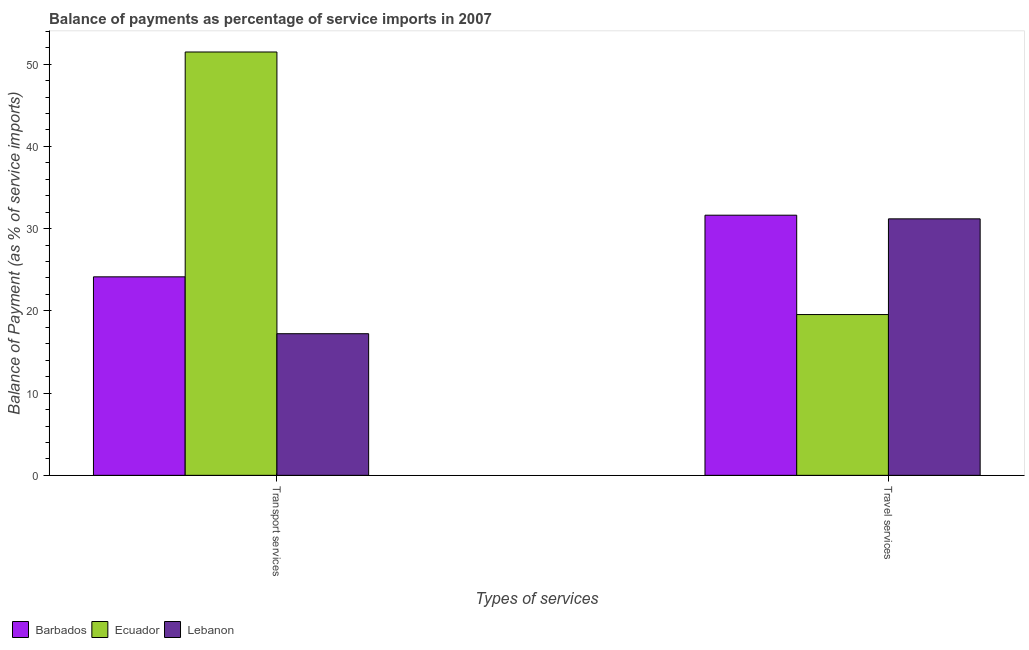How many groups of bars are there?
Your response must be concise. 2. Are the number of bars per tick equal to the number of legend labels?
Provide a succinct answer. Yes. Are the number of bars on each tick of the X-axis equal?
Give a very brief answer. Yes. How many bars are there on the 1st tick from the right?
Your answer should be very brief. 3. What is the label of the 2nd group of bars from the left?
Offer a very short reply. Travel services. What is the balance of payments of travel services in Ecuador?
Offer a very short reply. 19.55. Across all countries, what is the maximum balance of payments of travel services?
Ensure brevity in your answer.  31.64. Across all countries, what is the minimum balance of payments of transport services?
Provide a short and direct response. 17.22. In which country was the balance of payments of travel services maximum?
Provide a succinct answer. Barbados. In which country was the balance of payments of travel services minimum?
Offer a terse response. Ecuador. What is the total balance of payments of transport services in the graph?
Offer a very short reply. 92.85. What is the difference between the balance of payments of travel services in Lebanon and that in Ecuador?
Make the answer very short. 11.64. What is the difference between the balance of payments of travel services in Barbados and the balance of payments of transport services in Lebanon?
Your answer should be very brief. 14.41. What is the average balance of payments of transport services per country?
Offer a very short reply. 30.95. What is the difference between the balance of payments of travel services and balance of payments of transport services in Barbados?
Offer a terse response. 7.49. What is the ratio of the balance of payments of travel services in Ecuador to that in Lebanon?
Make the answer very short. 0.63. What does the 3rd bar from the left in Transport services represents?
Provide a short and direct response. Lebanon. What does the 1st bar from the right in Travel services represents?
Provide a short and direct response. Lebanon. How many countries are there in the graph?
Make the answer very short. 3. What is the difference between two consecutive major ticks on the Y-axis?
Make the answer very short. 10. Are the values on the major ticks of Y-axis written in scientific E-notation?
Offer a terse response. No. Does the graph contain any zero values?
Your answer should be compact. No. Does the graph contain grids?
Give a very brief answer. No. What is the title of the graph?
Offer a terse response. Balance of payments as percentage of service imports in 2007. Does "Low income" appear as one of the legend labels in the graph?
Your answer should be very brief. No. What is the label or title of the X-axis?
Provide a succinct answer. Types of services. What is the label or title of the Y-axis?
Make the answer very short. Balance of Payment (as % of service imports). What is the Balance of Payment (as % of service imports) of Barbados in Transport services?
Make the answer very short. 24.14. What is the Balance of Payment (as % of service imports) of Ecuador in Transport services?
Keep it short and to the point. 51.48. What is the Balance of Payment (as % of service imports) of Lebanon in Transport services?
Your response must be concise. 17.22. What is the Balance of Payment (as % of service imports) of Barbados in Travel services?
Provide a succinct answer. 31.64. What is the Balance of Payment (as % of service imports) in Ecuador in Travel services?
Give a very brief answer. 19.55. What is the Balance of Payment (as % of service imports) in Lebanon in Travel services?
Keep it short and to the point. 31.19. Across all Types of services, what is the maximum Balance of Payment (as % of service imports) in Barbados?
Your response must be concise. 31.64. Across all Types of services, what is the maximum Balance of Payment (as % of service imports) of Ecuador?
Provide a short and direct response. 51.48. Across all Types of services, what is the maximum Balance of Payment (as % of service imports) of Lebanon?
Your answer should be very brief. 31.19. Across all Types of services, what is the minimum Balance of Payment (as % of service imports) in Barbados?
Provide a succinct answer. 24.14. Across all Types of services, what is the minimum Balance of Payment (as % of service imports) in Ecuador?
Keep it short and to the point. 19.55. Across all Types of services, what is the minimum Balance of Payment (as % of service imports) of Lebanon?
Provide a succinct answer. 17.22. What is the total Balance of Payment (as % of service imports) of Barbados in the graph?
Offer a terse response. 55.78. What is the total Balance of Payment (as % of service imports) in Ecuador in the graph?
Offer a very short reply. 71.03. What is the total Balance of Payment (as % of service imports) of Lebanon in the graph?
Offer a terse response. 48.41. What is the difference between the Balance of Payment (as % of service imports) in Barbados in Transport services and that in Travel services?
Make the answer very short. -7.49. What is the difference between the Balance of Payment (as % of service imports) of Ecuador in Transport services and that in Travel services?
Offer a terse response. 31.93. What is the difference between the Balance of Payment (as % of service imports) of Lebanon in Transport services and that in Travel services?
Keep it short and to the point. -13.97. What is the difference between the Balance of Payment (as % of service imports) of Barbados in Transport services and the Balance of Payment (as % of service imports) of Ecuador in Travel services?
Give a very brief answer. 4.59. What is the difference between the Balance of Payment (as % of service imports) in Barbados in Transport services and the Balance of Payment (as % of service imports) in Lebanon in Travel services?
Give a very brief answer. -7.05. What is the difference between the Balance of Payment (as % of service imports) in Ecuador in Transport services and the Balance of Payment (as % of service imports) in Lebanon in Travel services?
Offer a very short reply. 20.29. What is the average Balance of Payment (as % of service imports) in Barbados per Types of services?
Give a very brief answer. 27.89. What is the average Balance of Payment (as % of service imports) in Ecuador per Types of services?
Offer a terse response. 35.52. What is the average Balance of Payment (as % of service imports) in Lebanon per Types of services?
Provide a succinct answer. 24.21. What is the difference between the Balance of Payment (as % of service imports) in Barbados and Balance of Payment (as % of service imports) in Ecuador in Transport services?
Provide a short and direct response. -27.34. What is the difference between the Balance of Payment (as % of service imports) of Barbados and Balance of Payment (as % of service imports) of Lebanon in Transport services?
Keep it short and to the point. 6.92. What is the difference between the Balance of Payment (as % of service imports) of Ecuador and Balance of Payment (as % of service imports) of Lebanon in Transport services?
Provide a short and direct response. 34.26. What is the difference between the Balance of Payment (as % of service imports) of Barbados and Balance of Payment (as % of service imports) of Ecuador in Travel services?
Provide a short and direct response. 12.08. What is the difference between the Balance of Payment (as % of service imports) in Barbados and Balance of Payment (as % of service imports) in Lebanon in Travel services?
Offer a very short reply. 0.44. What is the difference between the Balance of Payment (as % of service imports) in Ecuador and Balance of Payment (as % of service imports) in Lebanon in Travel services?
Keep it short and to the point. -11.64. What is the ratio of the Balance of Payment (as % of service imports) of Barbados in Transport services to that in Travel services?
Your answer should be compact. 0.76. What is the ratio of the Balance of Payment (as % of service imports) in Ecuador in Transport services to that in Travel services?
Your answer should be compact. 2.63. What is the ratio of the Balance of Payment (as % of service imports) of Lebanon in Transport services to that in Travel services?
Your answer should be compact. 0.55. What is the difference between the highest and the second highest Balance of Payment (as % of service imports) of Barbados?
Make the answer very short. 7.49. What is the difference between the highest and the second highest Balance of Payment (as % of service imports) of Ecuador?
Ensure brevity in your answer.  31.93. What is the difference between the highest and the second highest Balance of Payment (as % of service imports) in Lebanon?
Your answer should be compact. 13.97. What is the difference between the highest and the lowest Balance of Payment (as % of service imports) of Barbados?
Make the answer very short. 7.49. What is the difference between the highest and the lowest Balance of Payment (as % of service imports) in Ecuador?
Give a very brief answer. 31.93. What is the difference between the highest and the lowest Balance of Payment (as % of service imports) in Lebanon?
Your response must be concise. 13.97. 